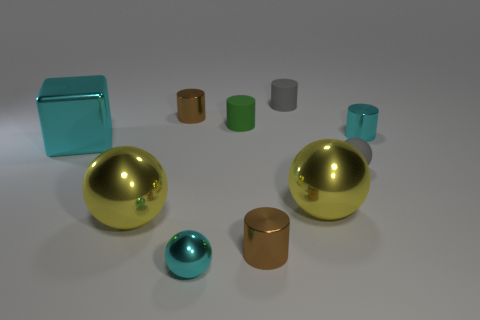Do the large cube and the tiny shiny sphere have the same color?
Ensure brevity in your answer.  Yes. What is the material of the brown cylinder behind the brown shiny object in front of the cyan metallic cylinder?
Provide a succinct answer. Metal. Are there any tiny cylinders that have the same material as the green object?
Offer a terse response. Yes. What is the shape of the small shiny thing to the right of the brown object that is right of the green rubber cylinder that is on the left side of the rubber ball?
Provide a short and direct response. Cylinder. What is the cyan cube made of?
Offer a very short reply. Metal. What is the color of the cube that is made of the same material as the cyan sphere?
Give a very brief answer. Cyan. Is there a large metallic block that is on the left side of the brown metal cylinder behind the cube?
Ensure brevity in your answer.  Yes. How many other objects are there of the same shape as the tiny green rubber object?
Keep it short and to the point. 4. Does the rubber thing in front of the green cylinder have the same shape as the gray rubber thing that is behind the small green cylinder?
Your answer should be very brief. No. How many small cylinders are on the right side of the matte cylinder in front of the tiny brown thing behind the tiny green rubber object?
Offer a very short reply. 3. 